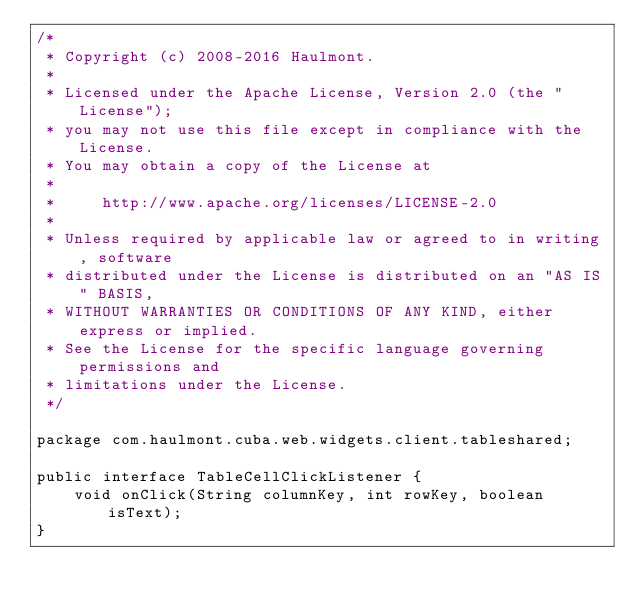<code> <loc_0><loc_0><loc_500><loc_500><_Java_>/*
 * Copyright (c) 2008-2016 Haulmont.
 *
 * Licensed under the Apache License, Version 2.0 (the "License");
 * you may not use this file except in compliance with the License.
 * You may obtain a copy of the License at
 *
 *     http://www.apache.org/licenses/LICENSE-2.0
 *
 * Unless required by applicable law or agreed to in writing, software
 * distributed under the License is distributed on an "AS IS" BASIS,
 * WITHOUT WARRANTIES OR CONDITIONS OF ANY KIND, either express or implied.
 * See the License for the specific language governing permissions and
 * limitations under the License.
 */

package com.haulmont.cuba.web.widgets.client.tableshared;

public interface TableCellClickListener {
    void onClick(String columnKey, int rowKey, boolean isText);
}</code> 